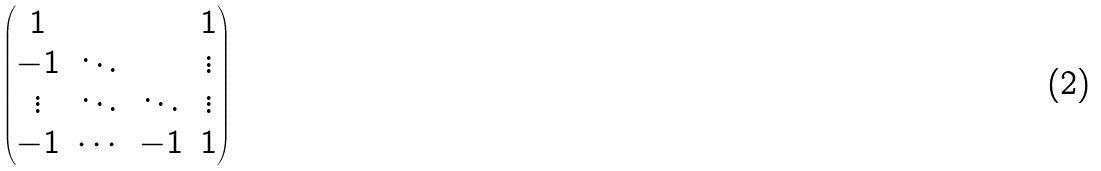Convert formula to latex. <formula><loc_0><loc_0><loc_500><loc_500>\begin{pmatrix} 1 & & & 1 \\ - 1 & \ddots & & \vdots \\ \vdots & \ddots & \ddots & \vdots \\ - 1 & \cdots & - 1 & 1 \end{pmatrix}</formula> 